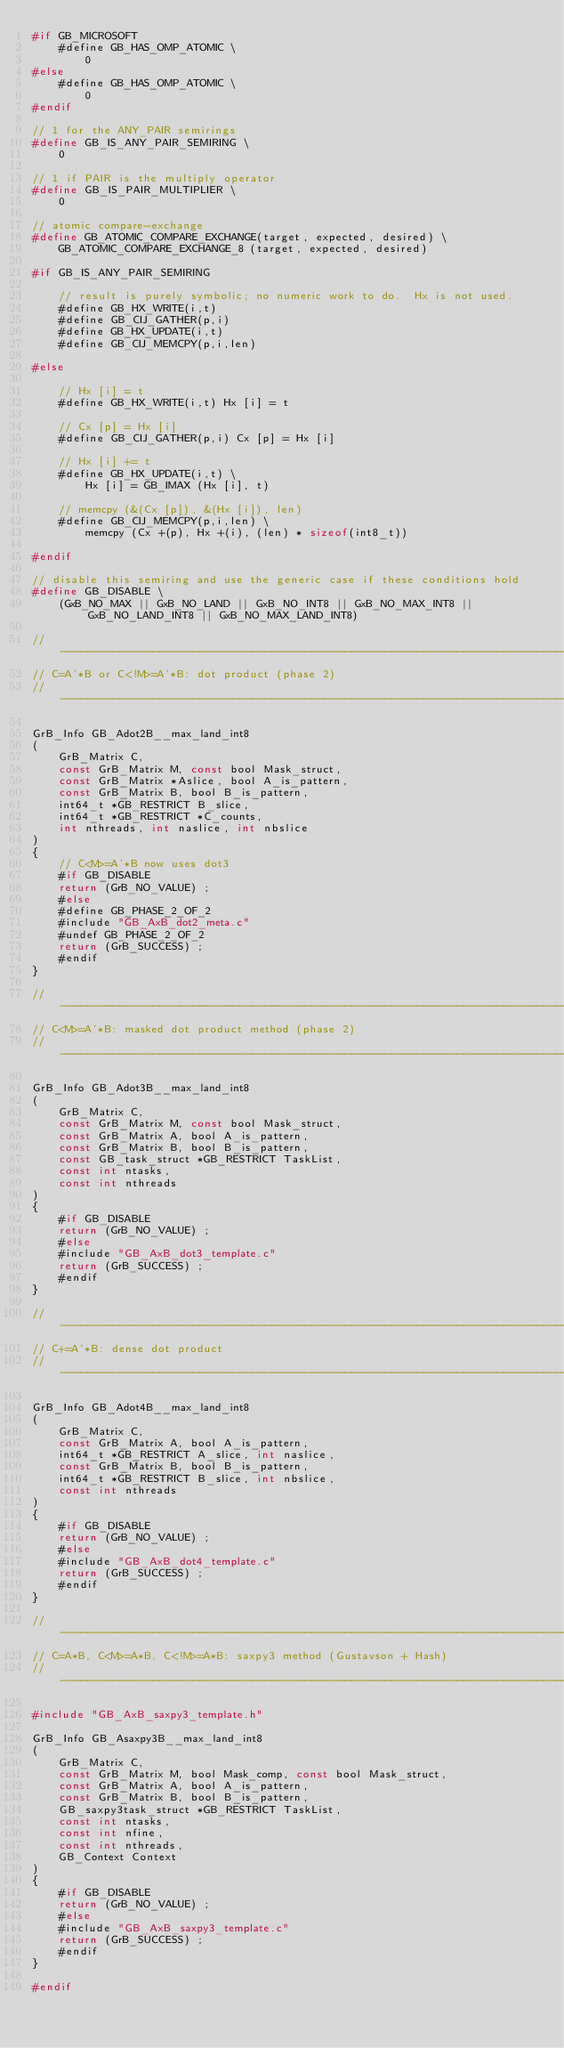<code> <loc_0><loc_0><loc_500><loc_500><_C_>#if GB_MICROSOFT
    #define GB_HAS_OMP_ATOMIC \
        0
#else
    #define GB_HAS_OMP_ATOMIC \
        0
#endif

// 1 for the ANY_PAIR semirings
#define GB_IS_ANY_PAIR_SEMIRING \
    0

// 1 if PAIR is the multiply operator 
#define GB_IS_PAIR_MULTIPLIER \
    0

// atomic compare-exchange
#define GB_ATOMIC_COMPARE_EXCHANGE(target, expected, desired) \
    GB_ATOMIC_COMPARE_EXCHANGE_8 (target, expected, desired)

#if GB_IS_ANY_PAIR_SEMIRING

    // result is purely symbolic; no numeric work to do.  Hx is not used.
    #define GB_HX_WRITE(i,t)
    #define GB_CIJ_GATHER(p,i)
    #define GB_HX_UPDATE(i,t)
    #define GB_CIJ_MEMCPY(p,i,len)

#else

    // Hx [i] = t
    #define GB_HX_WRITE(i,t) Hx [i] = t

    // Cx [p] = Hx [i]
    #define GB_CIJ_GATHER(p,i) Cx [p] = Hx [i]

    // Hx [i] += t
    #define GB_HX_UPDATE(i,t) \
        Hx [i] = GB_IMAX (Hx [i], t)

    // memcpy (&(Cx [p]), &(Hx [i]), len)
    #define GB_CIJ_MEMCPY(p,i,len) \
        memcpy (Cx +(p), Hx +(i), (len) * sizeof(int8_t))

#endif

// disable this semiring and use the generic case if these conditions hold
#define GB_DISABLE \
    (GxB_NO_MAX || GxB_NO_LAND || GxB_NO_INT8 || GxB_NO_MAX_INT8 || GxB_NO_LAND_INT8 || GxB_NO_MAX_LAND_INT8)

//------------------------------------------------------------------------------
// C=A'*B or C<!M>=A'*B: dot product (phase 2)
//------------------------------------------------------------------------------

GrB_Info GB_Adot2B__max_land_int8
(
    GrB_Matrix C,
    const GrB_Matrix M, const bool Mask_struct,
    const GrB_Matrix *Aslice, bool A_is_pattern,
    const GrB_Matrix B, bool B_is_pattern,
    int64_t *GB_RESTRICT B_slice,
    int64_t *GB_RESTRICT *C_counts,
    int nthreads, int naslice, int nbslice
)
{ 
    // C<M>=A'*B now uses dot3
    #if GB_DISABLE
    return (GrB_NO_VALUE) ;
    #else
    #define GB_PHASE_2_OF_2
    #include "GB_AxB_dot2_meta.c"
    #undef GB_PHASE_2_OF_2
    return (GrB_SUCCESS) ;
    #endif
}

//------------------------------------------------------------------------------
// C<M>=A'*B: masked dot product method (phase 2)
//------------------------------------------------------------------------------

GrB_Info GB_Adot3B__max_land_int8
(
    GrB_Matrix C,
    const GrB_Matrix M, const bool Mask_struct,
    const GrB_Matrix A, bool A_is_pattern,
    const GrB_Matrix B, bool B_is_pattern,
    const GB_task_struct *GB_RESTRICT TaskList,
    const int ntasks,
    const int nthreads
)
{ 
    #if GB_DISABLE
    return (GrB_NO_VALUE) ;
    #else
    #include "GB_AxB_dot3_template.c"
    return (GrB_SUCCESS) ;
    #endif
}

//------------------------------------------------------------------------------
// C+=A'*B: dense dot product
//------------------------------------------------------------------------------

GrB_Info GB_Adot4B__max_land_int8
(
    GrB_Matrix C,
    const GrB_Matrix A, bool A_is_pattern,
    int64_t *GB_RESTRICT A_slice, int naslice,
    const GrB_Matrix B, bool B_is_pattern,
    int64_t *GB_RESTRICT B_slice, int nbslice,
    const int nthreads
)
{ 
    #if GB_DISABLE
    return (GrB_NO_VALUE) ;
    #else
    #include "GB_AxB_dot4_template.c"
    return (GrB_SUCCESS) ;
    #endif
}

//------------------------------------------------------------------------------
// C=A*B, C<M>=A*B, C<!M>=A*B: saxpy3 method (Gustavson + Hash)
//------------------------------------------------------------------------------

#include "GB_AxB_saxpy3_template.h"

GrB_Info GB_Asaxpy3B__max_land_int8
(
    GrB_Matrix C,
    const GrB_Matrix M, bool Mask_comp, const bool Mask_struct,
    const GrB_Matrix A, bool A_is_pattern,
    const GrB_Matrix B, bool B_is_pattern,
    GB_saxpy3task_struct *GB_RESTRICT TaskList,
    const int ntasks,
    const int nfine,
    const int nthreads,
    GB_Context Context
)
{ 
    #if GB_DISABLE
    return (GrB_NO_VALUE) ;
    #else
    #include "GB_AxB_saxpy3_template.c"
    return (GrB_SUCCESS) ;
    #endif
}

#endif

</code> 